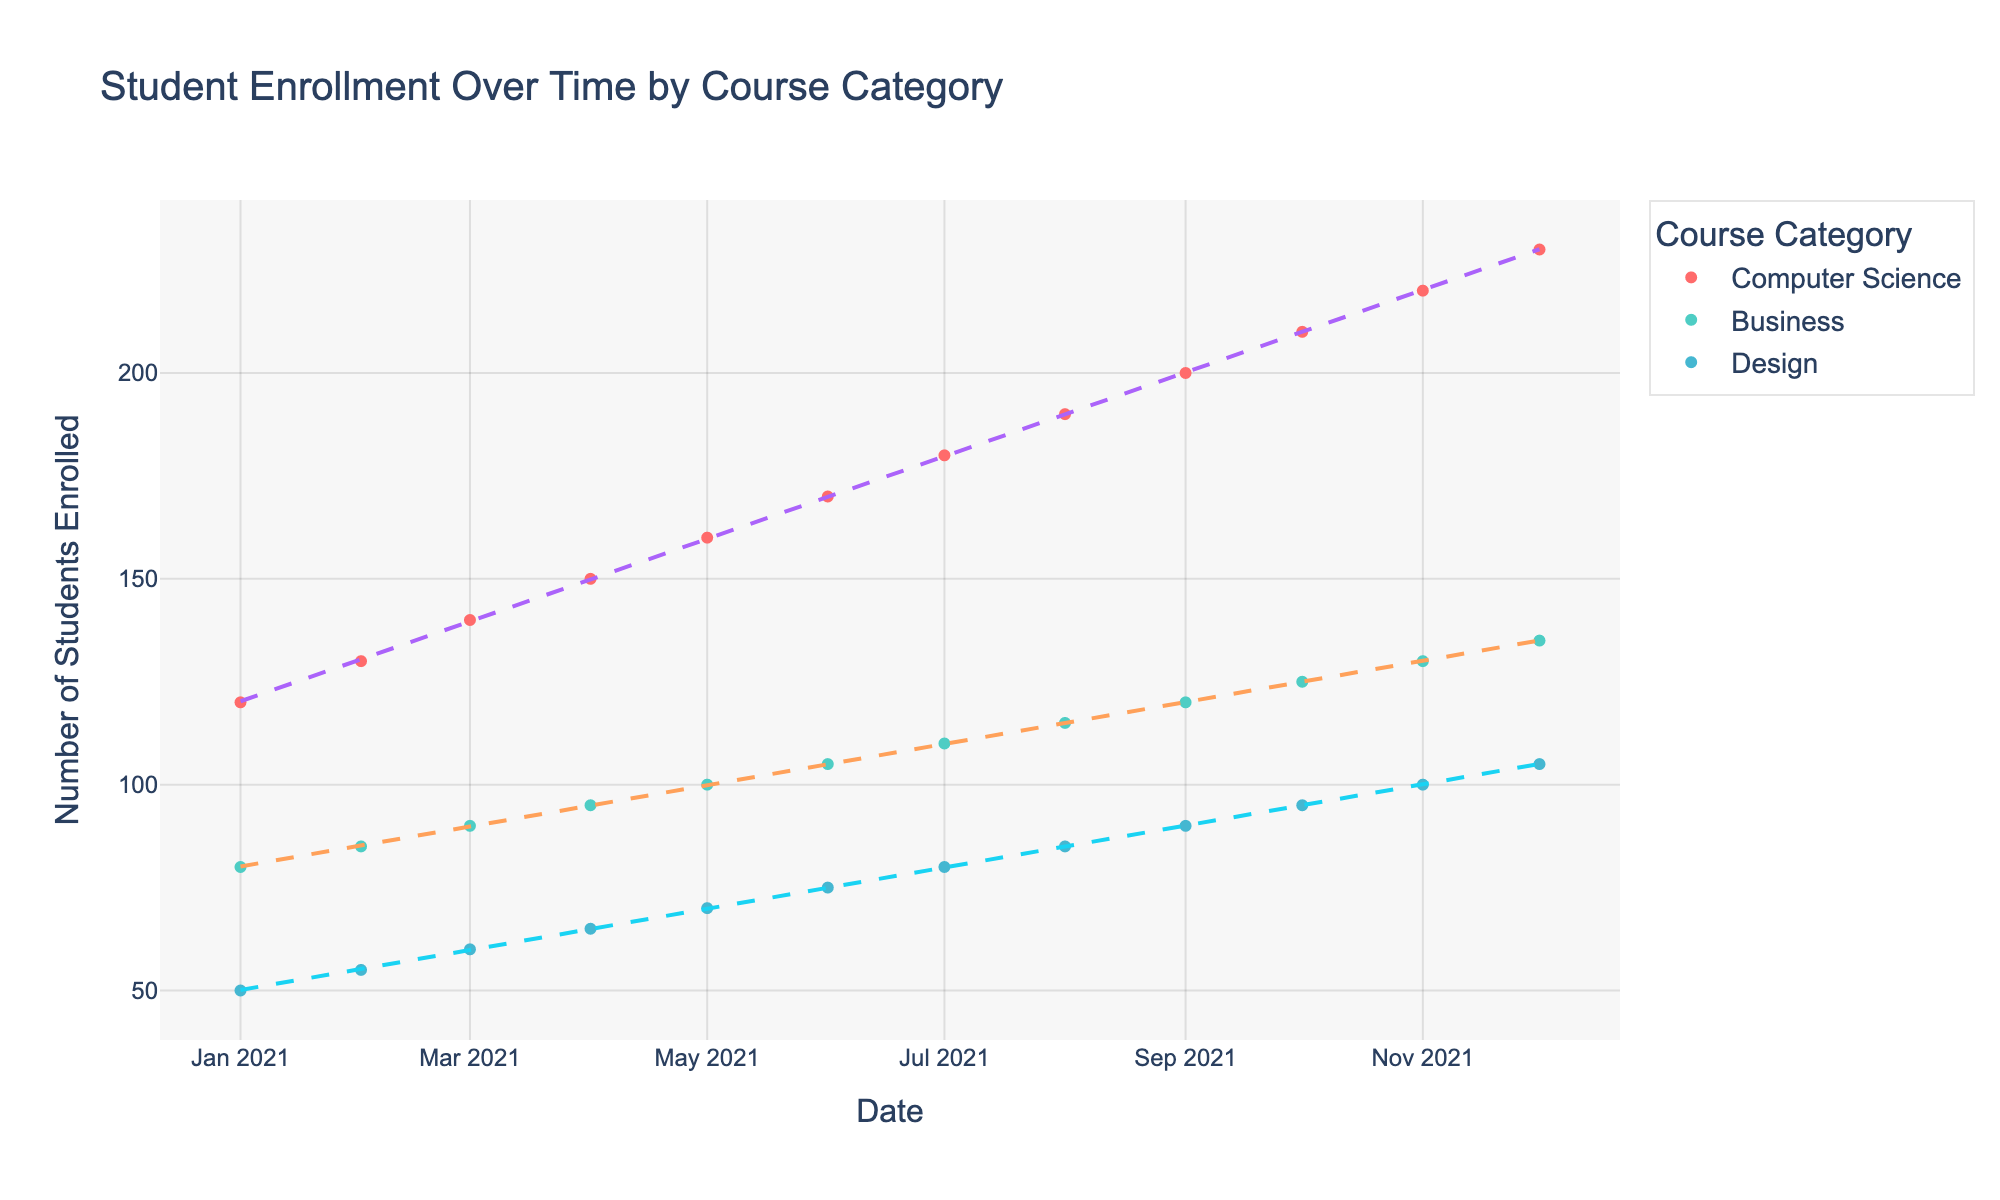What is the title of the plot? The title is clearly visible at the top of the plot and reads "Student Enrollment Over Time by Course Category".
Answer: Student Enrollment Over Time by Course Category What is the color used for representing the Computer Science category? Each course category is represented in a different color. The color used for Computer Science is red.
Answer: Red Over how many months is the data spread out? The data points on the x-axis represent different months. Counting the data points from January to December, we can see the data spans over 12 months.
Answer: 12 months What trend can be observed for the Business course category over time? The trend line for the Business category shows a steady increase in student enrollment over time.
Answer: Steady increase What is the enrollment for the Design course in November 2021? Locate the data point for November 2021 under the Design category. The y-axis shows an enrollment of 100 students.
Answer: 100 students Which course category shows the highest enrollment in December 2021? By examining the data points in December 2021, identify which category has the highest value on the y-axis. Computer Science has the highest enrollment with 230 students.
Answer: Computer Science Compare the enrollment growth between Computer Science and Business from January to December 2021. Compute the growth for both categories from January to December. Computer Science starts at 120 and ends at 230 (growth of 110), while Business starts at 80 and ends at 135 (growth of 55).
Answer: Computer Science has a higher enrollment growth How does the enrollment in October 2021 for the Design course compare to the enrollment in July 2021 for the same course? Locate the data points for Design in October and July 2021 on the plot. October shows 95 students, and July shows 80 students, so October has higher enrollment.
Answer: October enrollment is higher Identify the month in which the Business course had the lowest enrollment in 2021. Examine the Business category data points along the x-axis. The lowest enrollment is in January 2021 with 80 students.
Answer: January 2021 What can be inferred about the trend lines for each course category? The trend lines show the general enrollment increase. Computer Science has the steepest trend line, indicating a rapid increase. Business and Design have more moderate but steady increases.
Answer: All categories show an increasing trend, with Computer Science increasing the fastest 